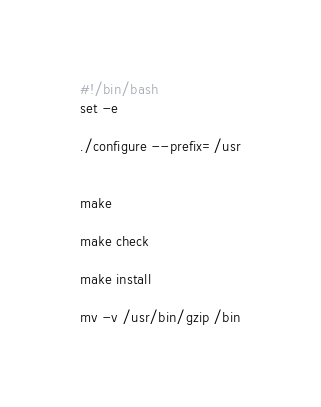<code> <loc_0><loc_0><loc_500><loc_500><_Bash_>#!/bin/bash
set -e

./configure --prefix=/usr


make 

make check

make install

mv -v /usr/bin/gzip /bin
</code> 